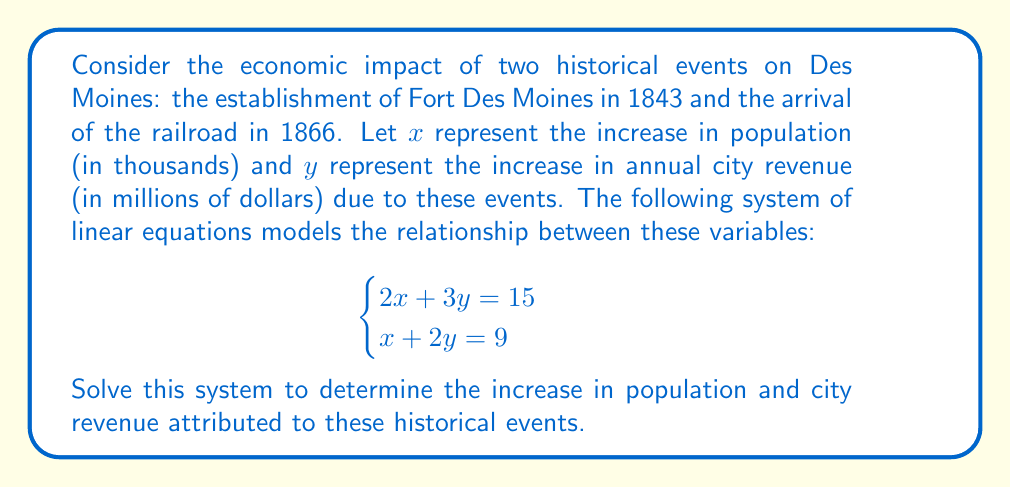Can you solve this math problem? To solve this system of linear equations, we'll use the elimination method:

1) Multiply the second equation by 2:
   $$\begin{cases}
   2x + 3y = 15 \\
   2x + 4y = 18
   \end{cases}$$

2) Subtract the first equation from the second:
   $y = 3$

3) Substitute $y = 3$ into the first equation:
   $2x + 3(3) = 15$
   $2x + 9 = 15$
   $2x = 6$
   $x = 3$

4) Therefore, the solution is $x = 3$ and $y = 3$

5) Interpret the results:
   - The population increased by 3,000 people ($x = 3$ thousand)
   - The annual city revenue increased by $3 million ($y = 3$ million dollars)
Answer: Population increase: 3,000; Revenue increase: $3 million 